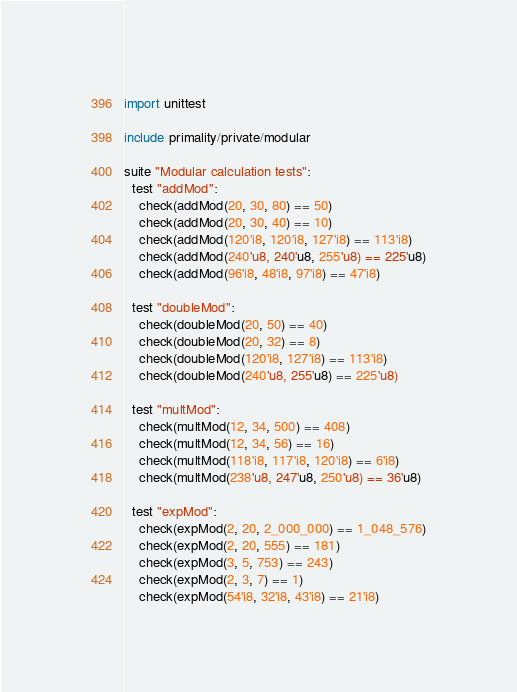<code> <loc_0><loc_0><loc_500><loc_500><_Nim_>import unittest

include primality/private/modular

suite "Modular calculation tests":
  test "addMod":
    check(addMod(20, 30, 80) == 50)
    check(addMod(20, 30, 40) == 10)
    check(addMod(120'i8, 120'i8, 127'i8) == 113'i8)
    check(addMod(240'u8, 240'u8, 255'u8) == 225'u8)
    check(addMod(96'i8, 48'i8, 97'i8) == 47'i8)

  test "doubleMod":
    check(doubleMod(20, 50) == 40)
    check(doubleMod(20, 32) == 8)
    check(doubleMod(120'i8, 127'i8) == 113'i8)
    check(doubleMod(240'u8, 255'u8) == 225'u8)

  test "multMod":
    check(multMod(12, 34, 500) == 408)
    check(multMod(12, 34, 56) == 16)
    check(multMod(118'i8, 117'i8, 120'i8) == 6'i8)
    check(multMod(238'u8, 247'u8, 250'u8) == 36'u8)

  test "expMod":
    check(expMod(2, 20, 2_000_000) == 1_048_576)
    check(expMod(2, 20, 555) == 181)
    check(expMod(3, 5, 753) == 243)
    check(expMod(2, 3, 7) == 1)
    check(expMod(54'i8, 32'i8, 43'i8) == 21'i8)
</code> 